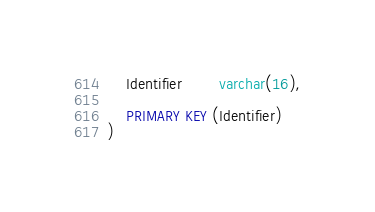<code> <loc_0><loc_0><loc_500><loc_500><_SQL_>	Identifier		varchar(16),

	PRIMARY KEY (Identifier)
)</code> 